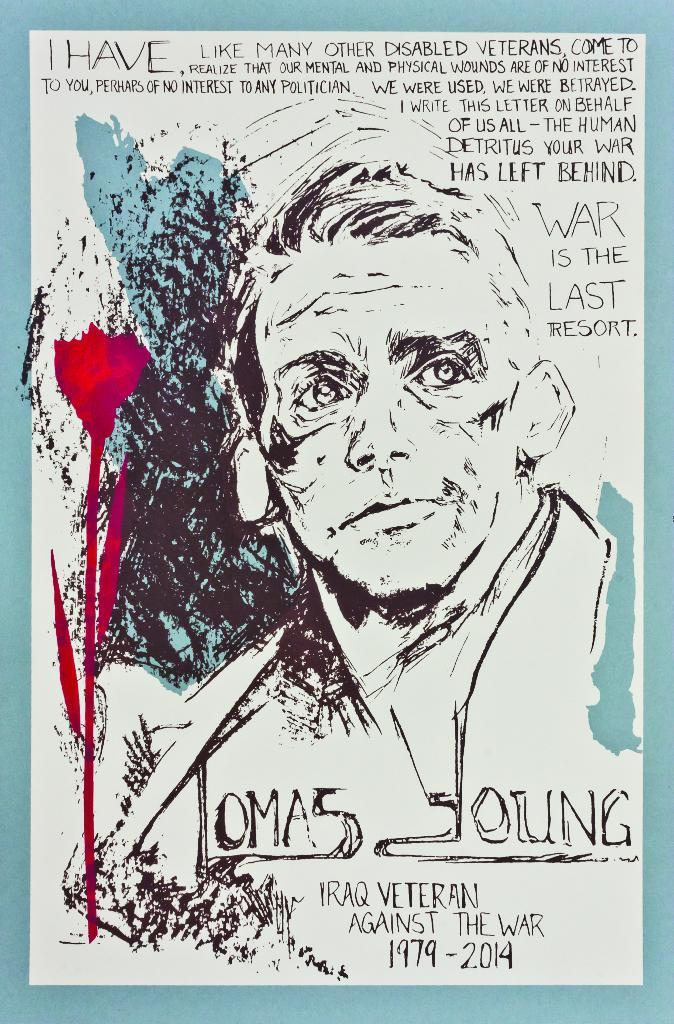What type of art is featured on the poster? The poster contains pencil art. What subjects are depicted in the pencil art? The pencil art depicts a man and a flower. Are there any words or letters on the poster? Yes, there are letters written on the poster. How many crows are perched on the man's shoulder in the pencil art? There are no crows depicted in the pencil art; it features a man and a flower. What type of industry is shown in the background of the pencil art? There is no industry depicted in the pencil art; it only features a man and a flower. 